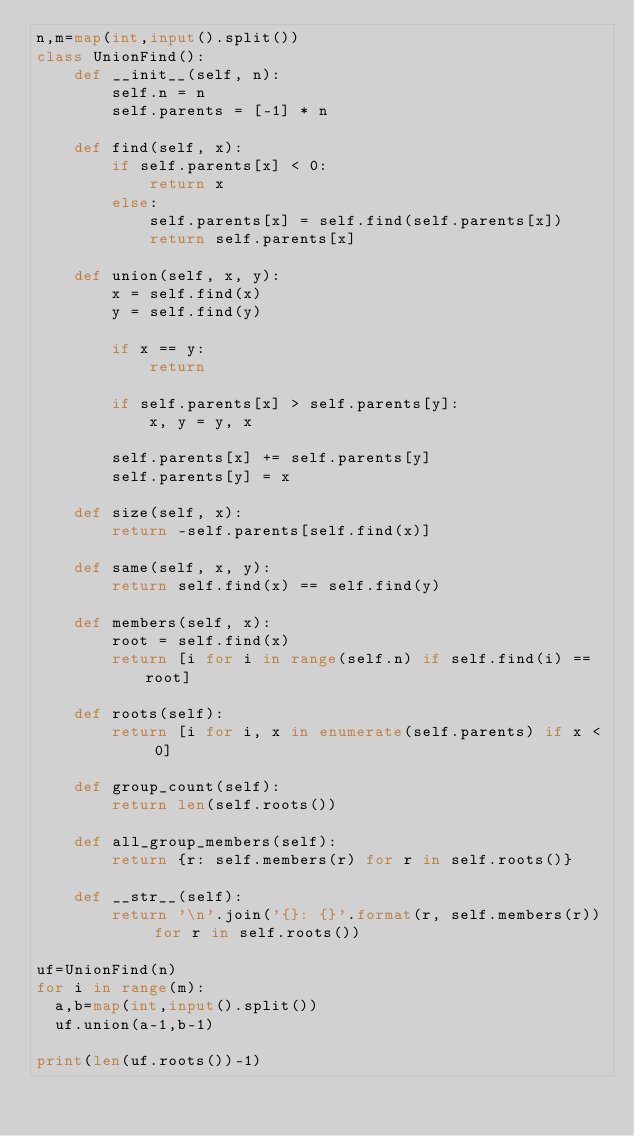Convert code to text. <code><loc_0><loc_0><loc_500><loc_500><_Python_>n,m=map(int,input().split())
class UnionFind():
    def __init__(self, n):
        self.n = n
        self.parents = [-1] * n

    def find(self, x):
        if self.parents[x] < 0:
            return x
        else:
            self.parents[x] = self.find(self.parents[x])
            return self.parents[x]

    def union(self, x, y):
        x = self.find(x)
        y = self.find(y)

        if x == y:
            return

        if self.parents[x] > self.parents[y]:
            x, y = y, x

        self.parents[x] += self.parents[y]
        self.parents[y] = x

    def size(self, x):
        return -self.parents[self.find(x)]

    def same(self, x, y):
        return self.find(x) == self.find(y)

    def members(self, x):
        root = self.find(x)
        return [i for i in range(self.n) if self.find(i) == root]

    def roots(self):
        return [i for i, x in enumerate(self.parents) if x < 0]

    def group_count(self):
        return len(self.roots())

    def all_group_members(self):
        return {r: self.members(r) for r in self.roots()}

    def __str__(self):
        return '\n'.join('{}: {}'.format(r, self.members(r)) for r in self.roots())
      
uf=UnionFind(n)
for i in range(m):
  a,b=map(int,input().split())
  uf.union(a-1,b-1)

print(len(uf.roots())-1)</code> 